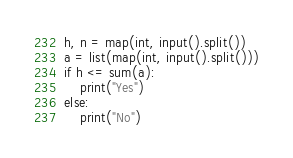<code> <loc_0><loc_0><loc_500><loc_500><_Python_>h, n = map(int, input().split())
a = list(map(int, input().split()))
if h <= sum(a):
    print("Yes")
else:
    print("No")</code> 